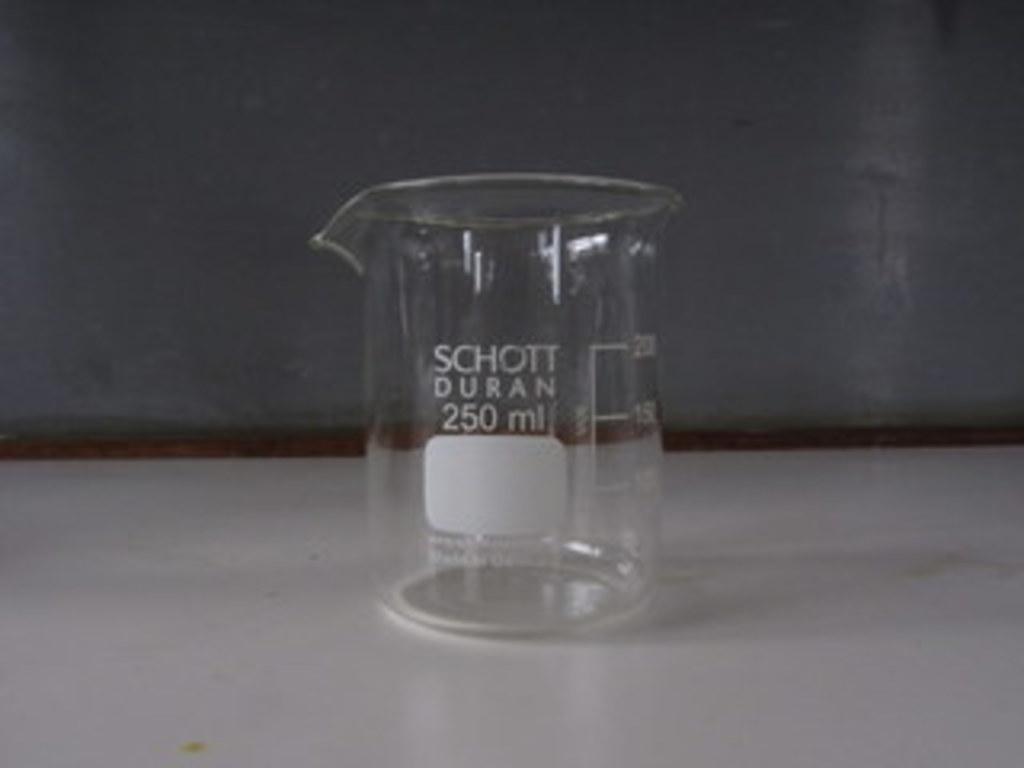Provide a one-sentence caption for the provided image. A 250 ml scientific glass container made by SCHOTT DURAN sits on a white counter. 